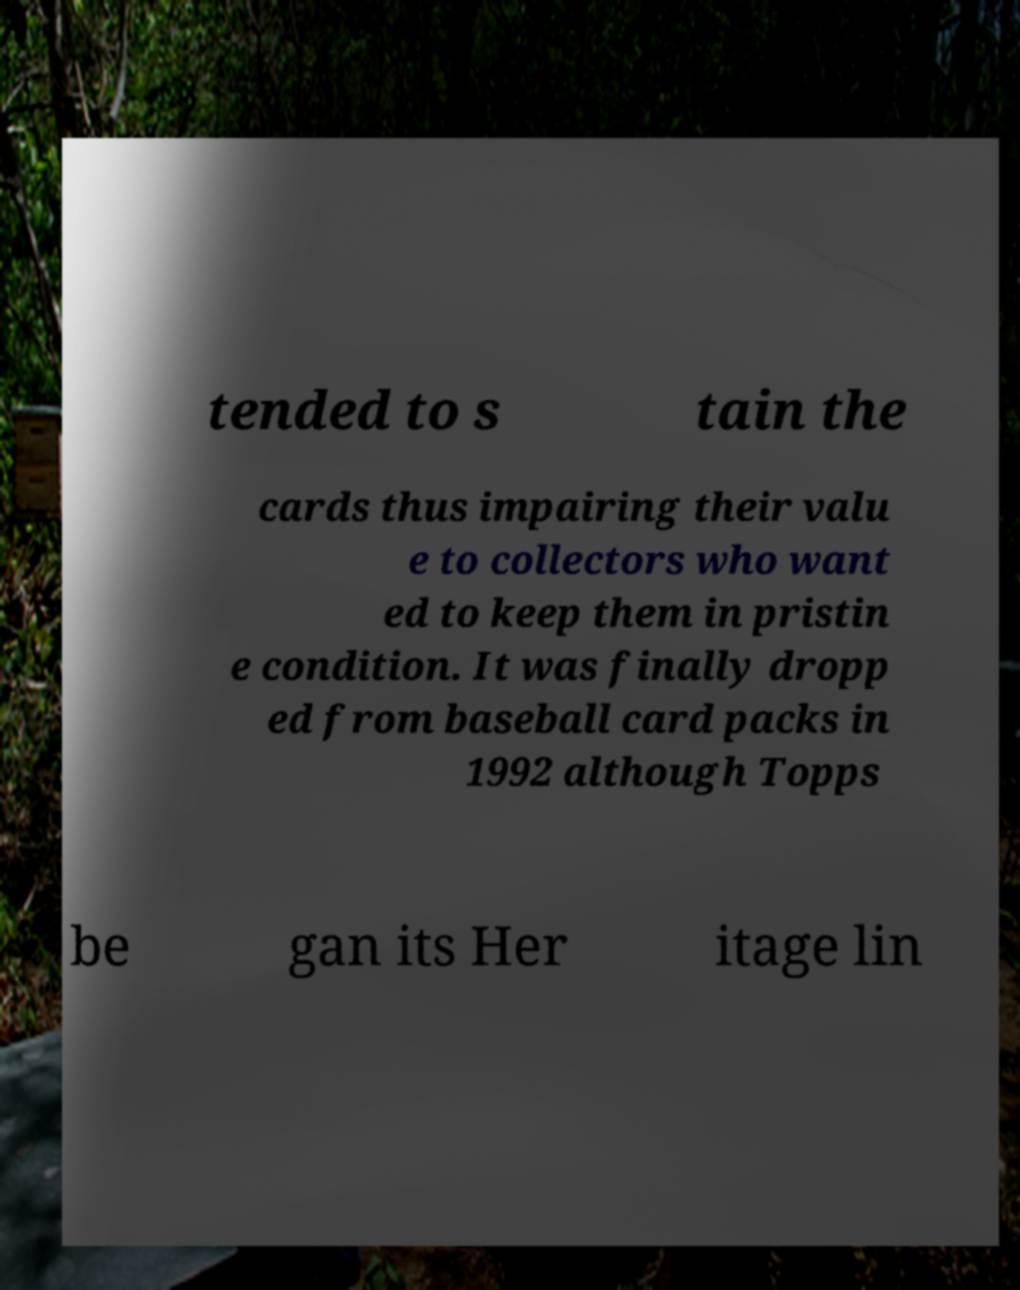Could you assist in decoding the text presented in this image and type it out clearly? tended to s tain the cards thus impairing their valu e to collectors who want ed to keep them in pristin e condition. It was finally dropp ed from baseball card packs in 1992 although Topps be gan its Her itage lin 